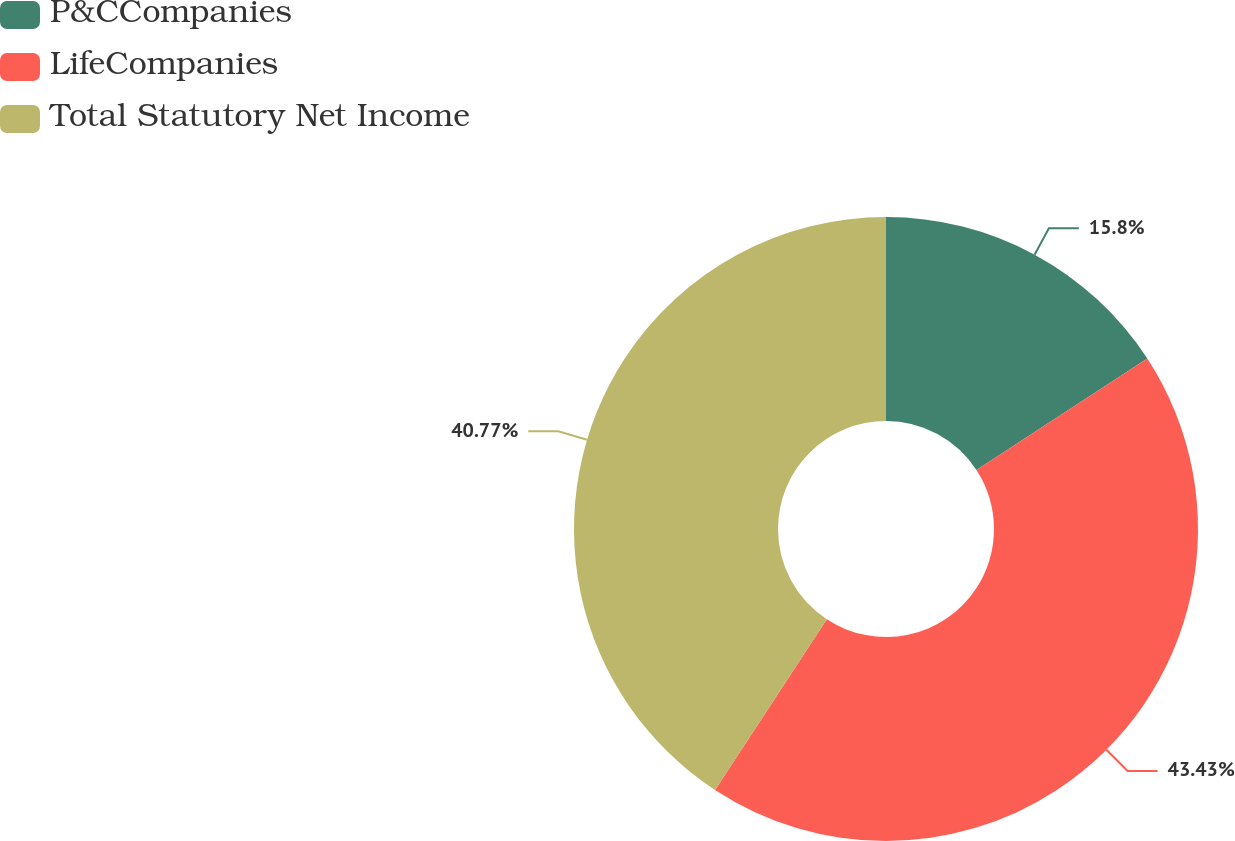Convert chart. <chart><loc_0><loc_0><loc_500><loc_500><pie_chart><fcel>P&CCompanies<fcel>LifeCompanies<fcel>Total Statutory Net Income<nl><fcel>15.8%<fcel>43.43%<fcel>40.77%<nl></chart> 